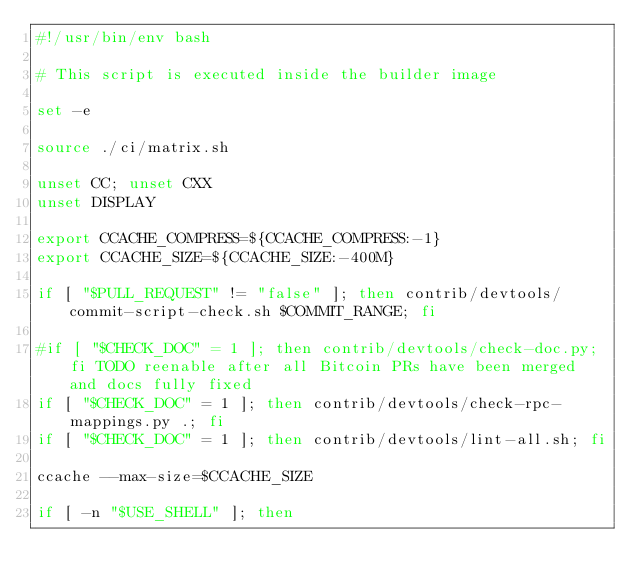Convert code to text. <code><loc_0><loc_0><loc_500><loc_500><_Bash_>#!/usr/bin/env bash

# This script is executed inside the builder image

set -e

source ./ci/matrix.sh

unset CC; unset CXX
unset DISPLAY

export CCACHE_COMPRESS=${CCACHE_COMPRESS:-1}
export CCACHE_SIZE=${CCACHE_SIZE:-400M}

if [ "$PULL_REQUEST" != "false" ]; then contrib/devtools/commit-script-check.sh $COMMIT_RANGE; fi

#if [ "$CHECK_DOC" = 1 ]; then contrib/devtools/check-doc.py; fi TODO reenable after all Bitcoin PRs have been merged and docs fully fixed
if [ "$CHECK_DOC" = 1 ]; then contrib/devtools/check-rpc-mappings.py .; fi
if [ "$CHECK_DOC" = 1 ]; then contrib/devtools/lint-all.sh; fi

ccache --max-size=$CCACHE_SIZE

if [ -n "$USE_SHELL" ]; then</code> 